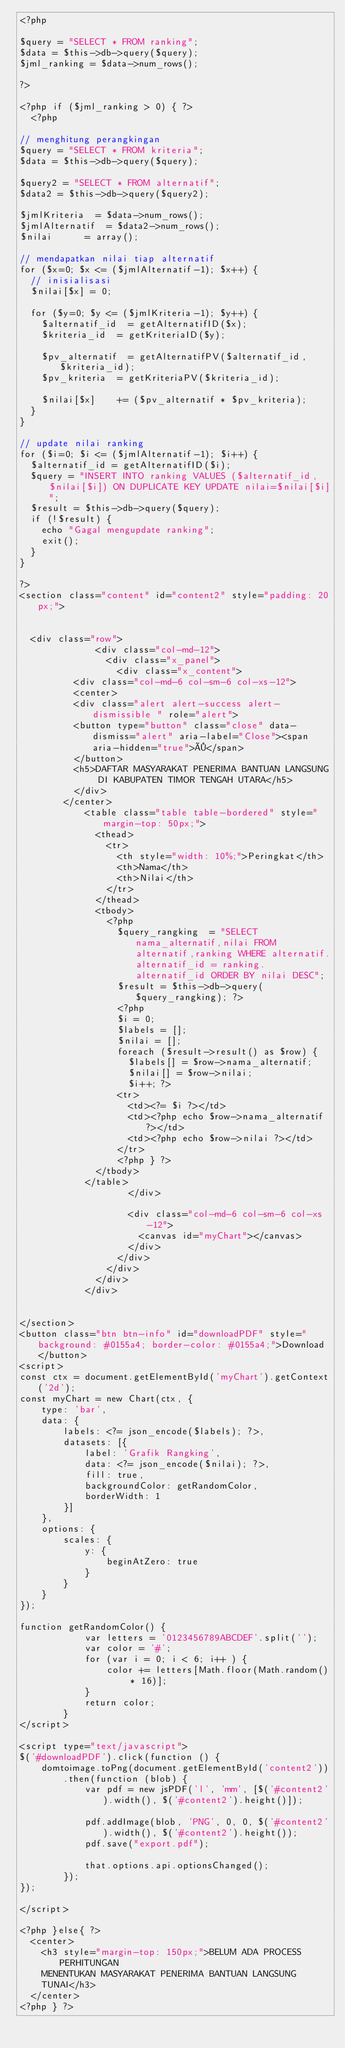Convert code to text. <code><loc_0><loc_0><loc_500><loc_500><_PHP_><?php

$query = "SELECT * FROM ranking";
$data = $this->db->query($query);
$jml_ranking = $data->num_rows();

?>

<?php if ($jml_ranking > 0) { ?>
	<?php

// menghitung perangkingan
$query = "SELECT * FROM kriteria";
$data = $this->db->query($query);

$query2 = "SELECT * FROM alternatif";
$data2 = $this->db->query($query2);

$jmlKriteria 	= $data->num_rows();
$jmlAlternatif	= $data2->num_rows();
$nilai			= array();

// mendapatkan nilai tiap alternatif
for ($x=0; $x <= ($jmlAlternatif-1); $x++) {
	// inisialisasi
	$nilai[$x] = 0;

	for ($y=0; $y <= ($jmlKriteria-1); $y++) {
		$alternatif_id 	= getAlternatifID($x);
		$kriteria_id	= getKriteriaID($y);

		$pv_alternatif	= getAlternatifPV($alternatif_id,$kriteria_id);
		$pv_kriteria	= getKriteriaPV($kriteria_id);

		$nilai[$x]	 	+= ($pv_alternatif * $pv_kriteria);
	}
}

// update nilai ranking
for ($i=0; $i <= ($jmlAlternatif-1); $i++) { 
	$alternatif_id = getAlternatifID($i);
	$query = "INSERT INTO ranking VALUES ($alternatif_id,$nilai[$i]) ON DUPLICATE KEY UPDATE nilai=$nilai[$i]";
	$result = $this->db->query($query);
	if (!$result) {
		echo "Gagal mengupdate ranking";
		exit();
	}
}

?>
<section class="content" id="content2" style="padding: 20px;">


	<div class="row">
              <div class="col-md-12">
                <div class="x_panel">
                  <div class="x_content">
				  <div class="col-md-6 col-sm-6 col-xs-12">
				  <center>
				  <div class="alert alert-success alert-dismissible " role="alert">
					<button type="button" class="close" data-dismiss="alert" aria-label="Close"><span aria-hidden="true">×</span>
					</button>
					<h5>DAFTAR MASYARAKAT PENERIMA BANTUAN LANGSUNG DI KABUPATEN TIMOR TENGAH UTARA</h5>
					</div>
				</center>
						<table class="table table-bordered" style="margin-top: 50px;">
							<thead>
								<tr>
									<th style="width: 10%;">Peringkat</th>
									<th>Nama</th>
									<th>Nilai</th>
								</tr>
							</thead>
							<tbody>
								<?php
									$query_rangking  = "SELECT nama_alternatif,nilai FROM alternatif,ranking WHERE alternatif.alternatif_id = ranking.alternatif_id ORDER BY nilai DESC";
									$result = $this->db->query($query_rangking); ?>
									<?php 
									$i = 0;
									$labels = [];
									$nilai = [];
									foreach ($result->result() as $row) {
										$labels[] = $row->nama_alternatif;
										$nilai[] = $row->nilai;
										$i++; ?>
									<tr>
										<td><?= $i ?></td>
										<td><?php echo $row->nama_alternatif ?></td>
										<td><?php echo $row->nilai ?></td>
									</tr>
									<?php } ?>
							</tbody>
						</table>
                    </div>

                    <div class="col-md-6 col-sm-6 col-xs-12">
                      <canvas id="myChart"></canvas>
                    </div>                   
                  </div>
                </div>
              </div>
            </div>
			
			
</section>
<button class="btn btn-info" id="downloadPDF" style="background: #0155a4; border-color: #0155a4;">Download</button>
<script>
const ctx = document.getElementById('myChart').getContext('2d');
const myChart = new Chart(ctx, {
    type: 'bar',
    data: {
        labels: <?= json_encode($labels); ?>,
        datasets: [{
            label: 'Grafik Rangking',
            data: <?= json_encode($nilai); ?>,
            fill: true,
            backgroundColor: getRandomColor,
            borderWidth: 1
        }]
    },
    options: {
        scales: {
            y: {
                beginAtZero: true
            }
        }
    }
});

function getRandomColor() {
            var letters = '0123456789ABCDEF'.split('');
            var color = '#';
            for (var i = 0; i < 6; i++ ) {
                color += letters[Math.floor(Math.random() * 16)];
            }
            return color;
        }
</script>

<script type="text/javascript">
$('#downloadPDF').click(function () {
    domtoimage.toPng(document.getElementById('content2'))
        .then(function (blob) {
            var pdf = new jsPDF('l', 'mm', [$('#content2').width(), $('#content2').height()]);

            pdf.addImage(blob, 'PNG', 0, 0, $('#content2').width(), $('#content2').height());
            pdf.save("export.pdf");

            that.options.api.optionsChanged();
        });
});

</script>
	
<?php }else{ ?>
	<center>
		<h3 style="margin-top: 150px;">BELUM ADA PROCESS PERHITUNGAN 
		MENENTUKAN MASYARAKAT PENERIMA BANTUAN LANGSUNG 
		TUNAI</h3>
	</center>
<?php } ?>






</code> 